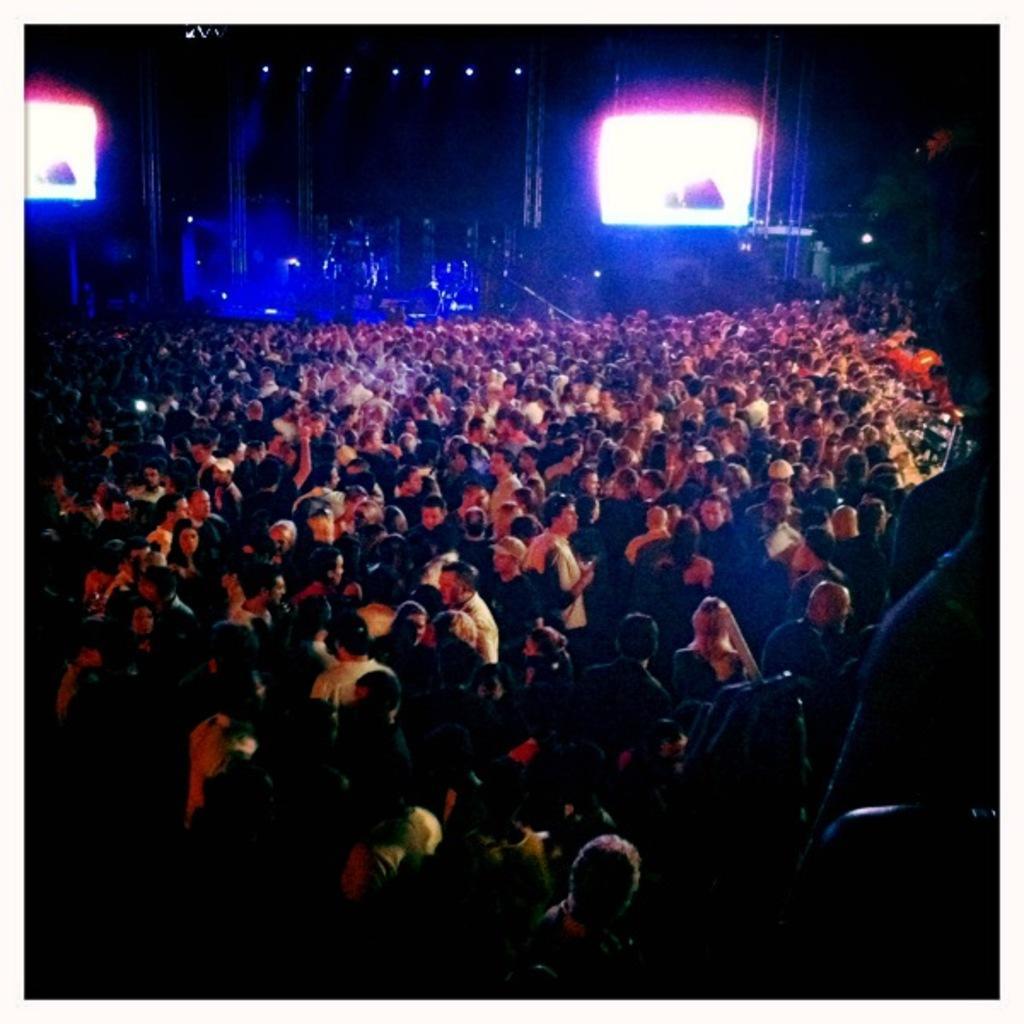Describe this image in one or two sentences. In this image we can see many people. In the background the image is dark but we can see screens, lights, rods and other objects. 